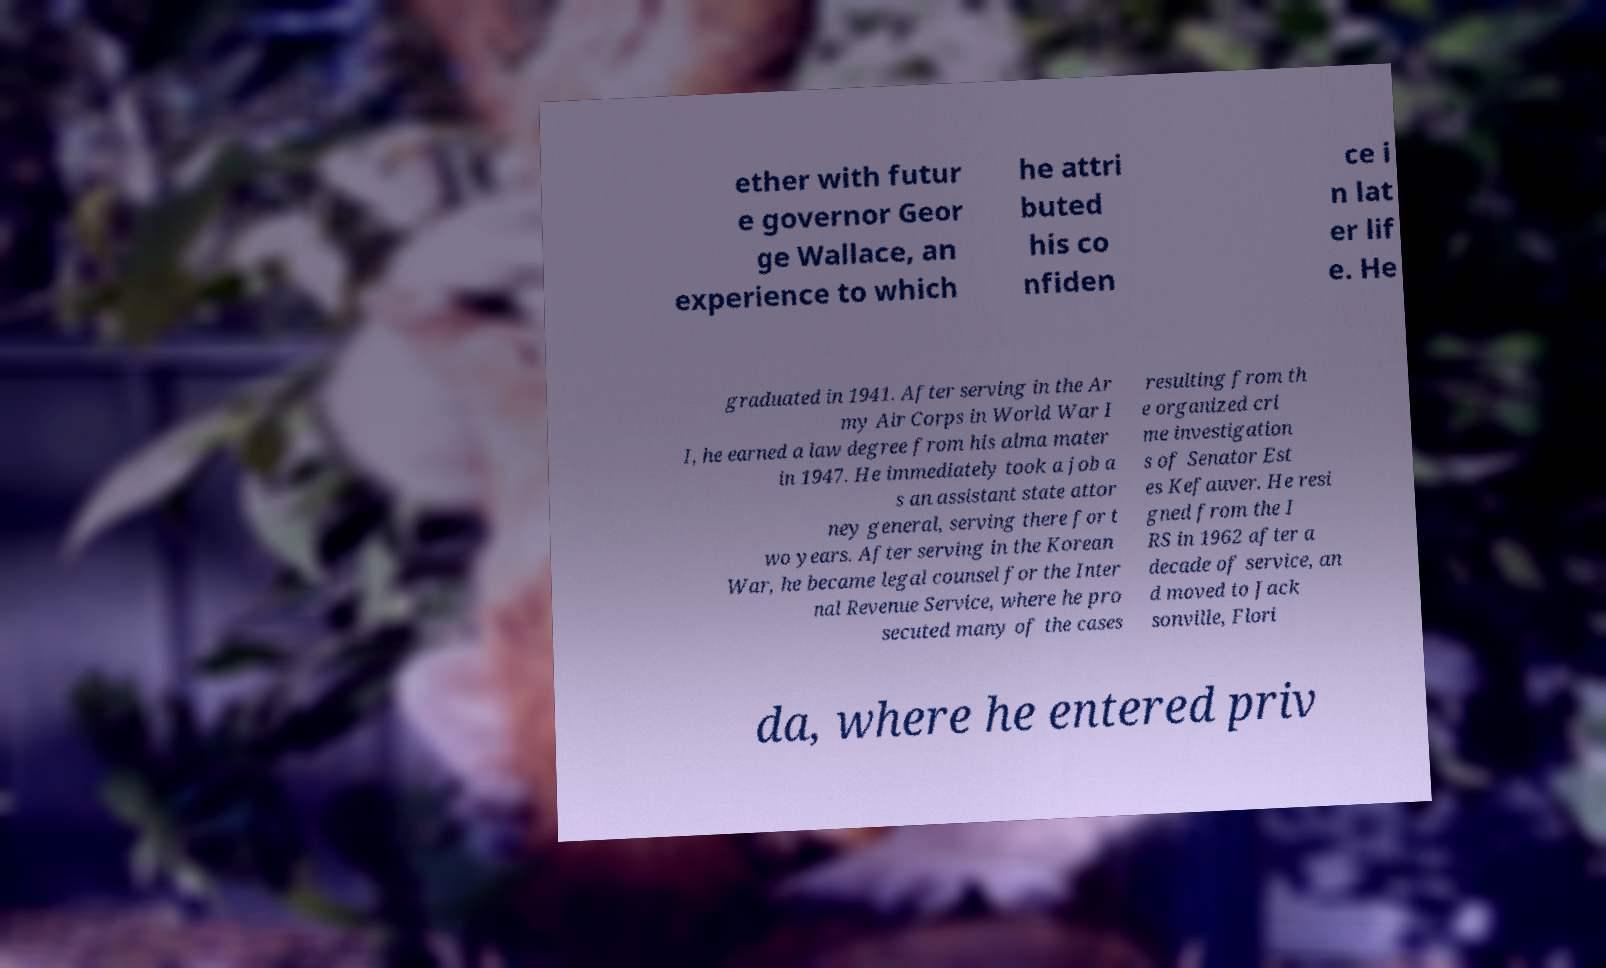Can you read and provide the text displayed in the image?This photo seems to have some interesting text. Can you extract and type it out for me? ether with futur e governor Geor ge Wallace, an experience to which he attri buted his co nfiden ce i n lat er lif e. He graduated in 1941. After serving in the Ar my Air Corps in World War I I, he earned a law degree from his alma mater in 1947. He immediately took a job a s an assistant state attor ney general, serving there for t wo years. After serving in the Korean War, he became legal counsel for the Inter nal Revenue Service, where he pro secuted many of the cases resulting from th e organized cri me investigation s of Senator Est es Kefauver. He resi gned from the I RS in 1962 after a decade of service, an d moved to Jack sonville, Flori da, where he entered priv 